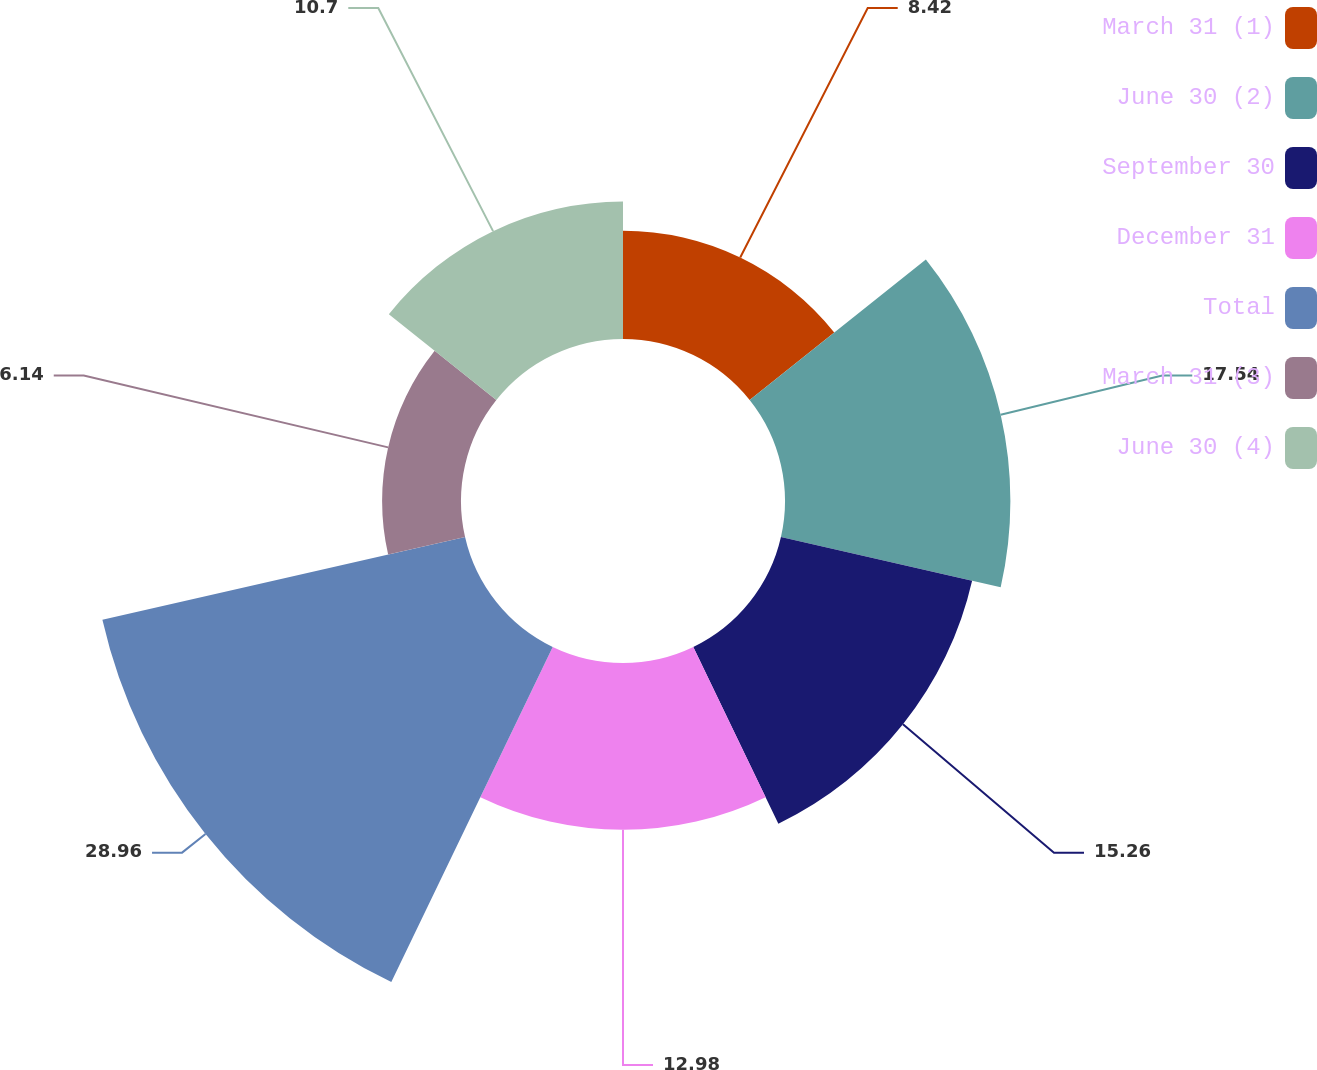Convert chart. <chart><loc_0><loc_0><loc_500><loc_500><pie_chart><fcel>March 31 (1)<fcel>June 30 (2)<fcel>September 30<fcel>December 31<fcel>Total<fcel>March 31 (3)<fcel>June 30 (4)<nl><fcel>8.42%<fcel>17.54%<fcel>15.26%<fcel>12.98%<fcel>28.95%<fcel>6.14%<fcel>10.7%<nl></chart> 